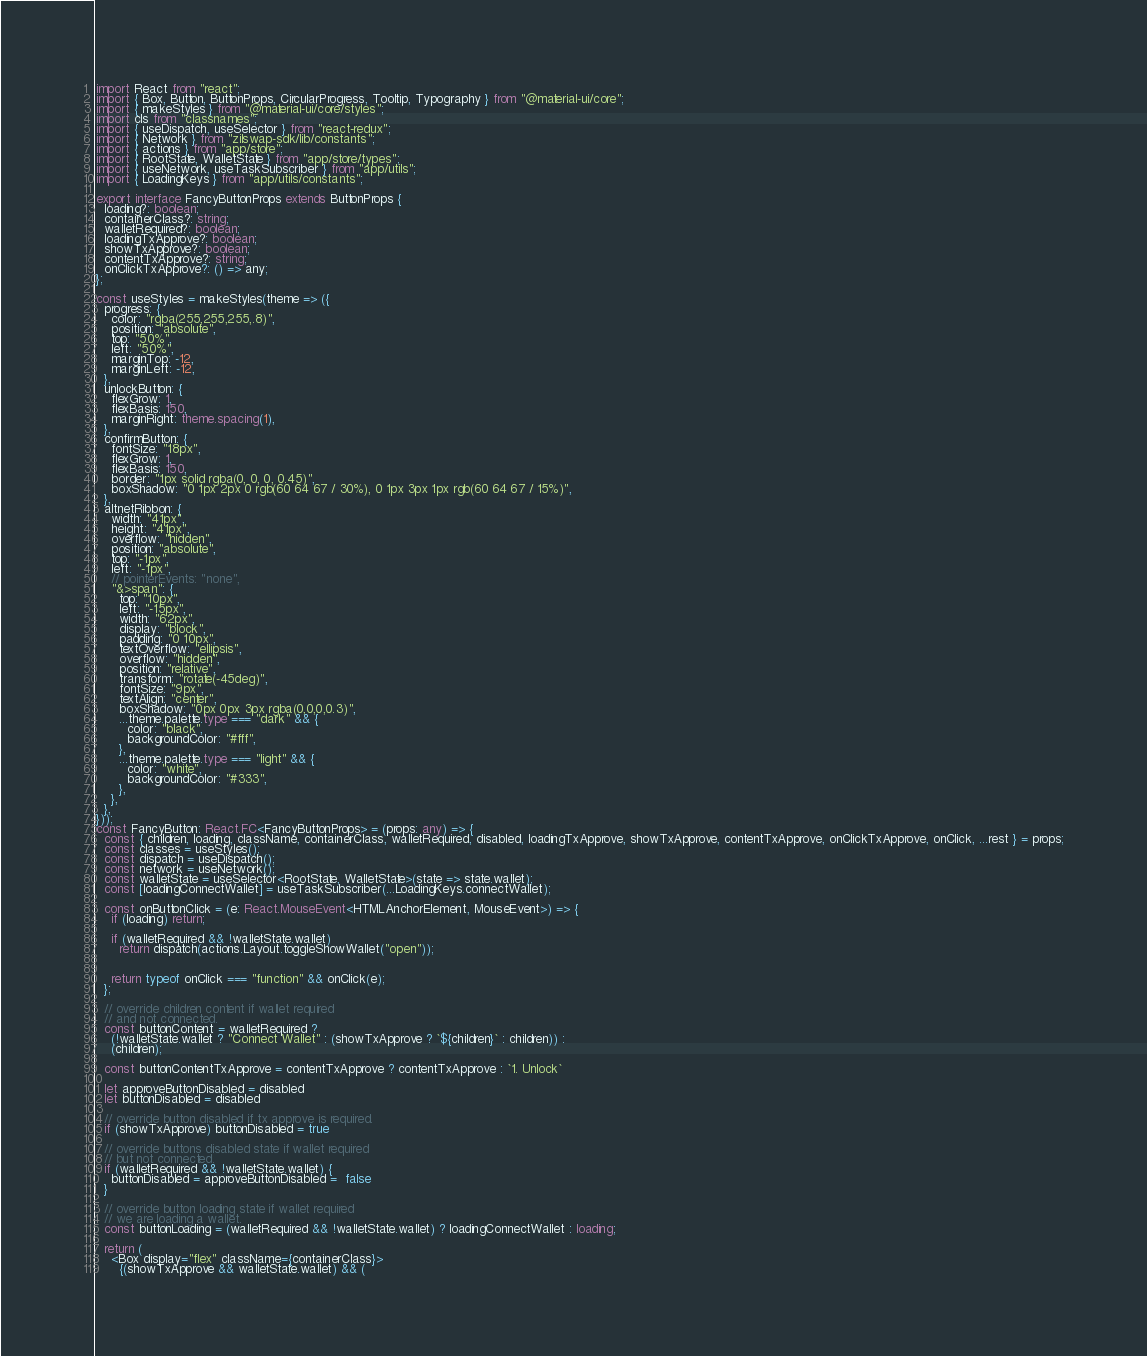Convert code to text. <code><loc_0><loc_0><loc_500><loc_500><_TypeScript_>import React from "react";
import { Box, Button, ButtonProps, CircularProgress, Tooltip, Typography } from "@material-ui/core";
import { makeStyles } from "@material-ui/core/styles";
import cls from "classnames";
import { useDispatch, useSelector } from "react-redux";
import { Network } from "zilswap-sdk/lib/constants";
import { actions } from "app/store";
import { RootState, WalletState } from "app/store/types";
import { useNetwork, useTaskSubscriber } from "app/utils";
import { LoadingKeys } from "app/utils/constants";

export interface FancyButtonProps extends ButtonProps {
  loading?: boolean;
  containerClass?: string;
  walletRequired?: boolean;
  loadingTxApprove?: boolean;
  showTxApprove?: boolean;
  contentTxApprove?: string;
  onClickTxApprove?: () => any;
};

const useStyles = makeStyles(theme => ({
  progress: {
    color: "rgba(255,255,255,.8)",
    position: "absolute",
    top: "50%",
    left: "50%",
    marginTop: -12,
    marginLeft: -12,
  },
  unlockButton: {
    flexGrow: 1,
    flexBasis: 150,
    marginRight: theme.spacing(1),
  },
  confirmButton: {
    fontSize: "18px",
    flexGrow: 1,
    flexBasis: 150,
    border: "1px solid rgba(0, 0, 0, 0.45)",
    boxShadow: "0 1px 2px 0 rgb(60 64 67 / 30%), 0 1px 3px 1px rgb(60 64 67 / 15%)",
  },
  altnetRibbon: {
    width: "41px",
    height: "41px",
    overflow: "hidden",
    position: "absolute",
    top: "-1px",
    left: "-1px",
    // pointerEvents: "none",
    "&>span": {
      top: "10px",
      left: "-15px",
      width: "62px",
      display: "block",
      padding: "0 10px",
      textOverflow: "ellipsis",
      overflow: "hidden",
      position: "relative",
      transform: "rotate(-45deg)",
      fontSize: "9px",
      textAlign: "center",
      boxShadow: "0px 0px 3px rgba(0,0,0,0.3)",
      ...theme.palette.type === "dark" && {
        color: "black",
        backgroundColor: "#fff",
      },
      ...theme.palette.type === "light" && {
        color: "white",
        backgroundColor: "#333",
      },
    },
  },
}));
const FancyButton: React.FC<FancyButtonProps> = (props: any) => {
  const { children, loading, className, containerClass, walletRequired, disabled, loadingTxApprove, showTxApprove, contentTxApprove, onClickTxApprove, onClick, ...rest } = props;
  const classes = useStyles();
  const dispatch = useDispatch();
  const network = useNetwork();
  const walletState = useSelector<RootState, WalletState>(state => state.wallet);
  const [loadingConnectWallet] = useTaskSubscriber(...LoadingKeys.connectWallet);

  const onButtonClick = (e: React.MouseEvent<HTMLAnchorElement, MouseEvent>) => {
    if (loading) return;

    if (walletRequired && !walletState.wallet)
      return dispatch(actions.Layout.toggleShowWallet("open"));


    return typeof onClick === "function" && onClick(e);
  };

  // override children content if wallet required
  // and not connected.
  const buttonContent = walletRequired ?
    (!walletState.wallet ? "Connect Wallet" : (showTxApprove ? `${children}` : children)) :
    (children);

  const buttonContentTxApprove = contentTxApprove ? contentTxApprove : `1. Unlock`

  let approveButtonDisabled = disabled
  let buttonDisabled = disabled

  // override button disabled if tx approve is required.
  if (showTxApprove) buttonDisabled = true

  // override buttons disabled state if wallet required
  // but not connected.
  if (walletRequired && !walletState.wallet) {
    buttonDisabled = approveButtonDisabled =  false
  }

  // override button loading state if wallet required
  // we are loading a wallet.
  const buttonLoading = (walletRequired && !walletState.wallet) ? loadingConnectWallet : loading;

  return (
    <Box display="flex" className={containerClass}>
      {(showTxApprove && walletState.wallet) && (</code> 